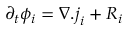<formula> <loc_0><loc_0><loc_500><loc_500>\partial _ { t } \phi _ { i } = \nabla . j _ { i } + R _ { i }</formula> 